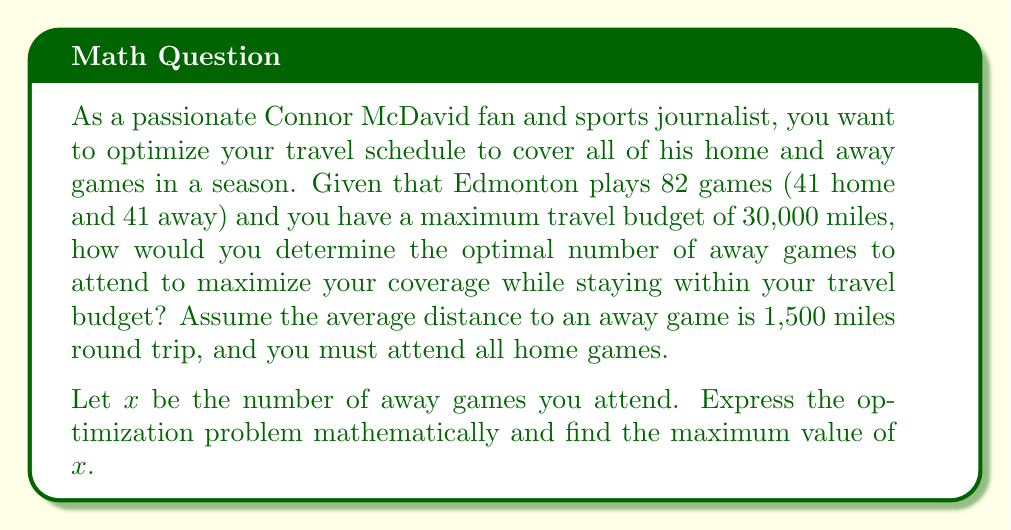Teach me how to tackle this problem. To solve this optimization problem, we need to set up the objective function and constraints based on the given information:

1. Objective function: Maximize $x$ (number of away games attended)

2. Constraints:
   - You must attend all 41 home games
   - The travel budget is 30,000 miles
   - Each away game requires an average of 1,500 miles of travel

Let's express this mathematically:

Maximize $x$

Subject to:
$$1500x \leq 30000$$

This inequality represents the travel budget constraint. The left side, $1500x$, is the total miles traveled for away games, which must be less than or equal to the budget of 30,000 miles.

To find the maximum value of $x$, we solve the inequality:

$$1500x \leq 30000$$
$$x \leq \frac{30000}{1500}$$
$$x \leq 20$$

Since $x$ represents the number of games, it must be a non-negative integer. Therefore, the maximum value of $x$ that satisfies the constraint is 20.

This means you can attend a maximum of 20 away games while staying within your travel budget.

To verify:
20 away games * 1,500 miles = 30,000 miles, which exactly meets the travel budget.

Total games covered: 41 home games + 20 away games = 61 games out of 82 total games in the season.
Answer: The maximum number of away games that can be attended while staying within the travel budget is 20 games. 